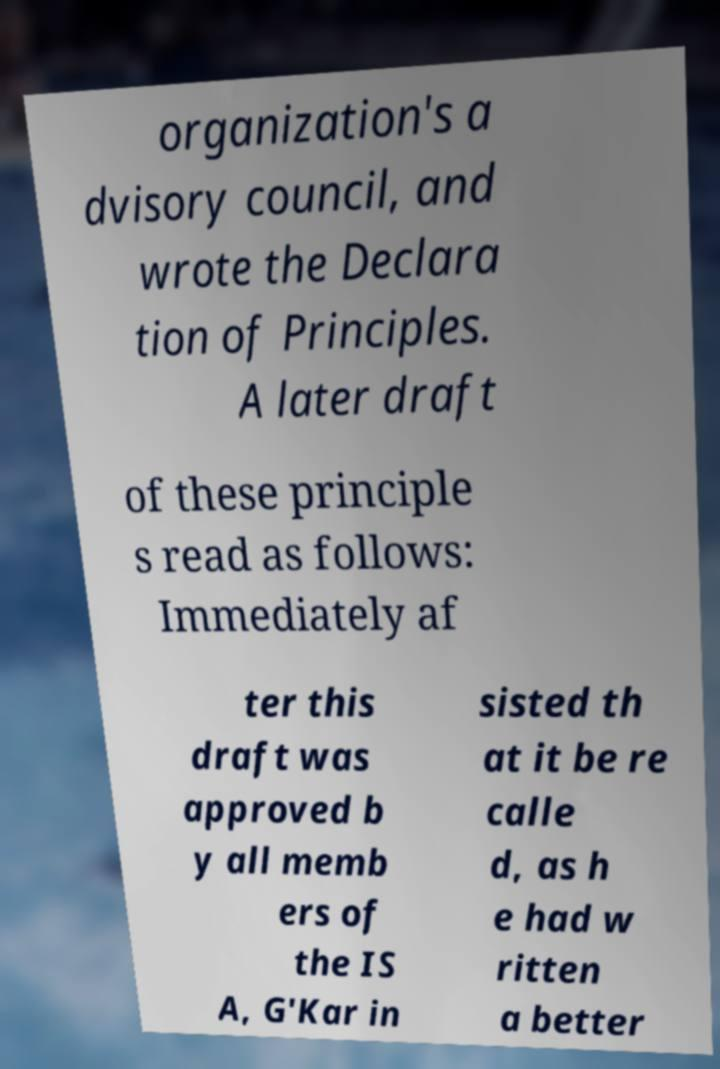Can you read and provide the text displayed in the image?This photo seems to have some interesting text. Can you extract and type it out for me? organization's a dvisory council, and wrote the Declara tion of Principles. A later draft of these principle s read as follows: Immediately af ter this draft was approved b y all memb ers of the IS A, G'Kar in sisted th at it be re calle d, as h e had w ritten a better 